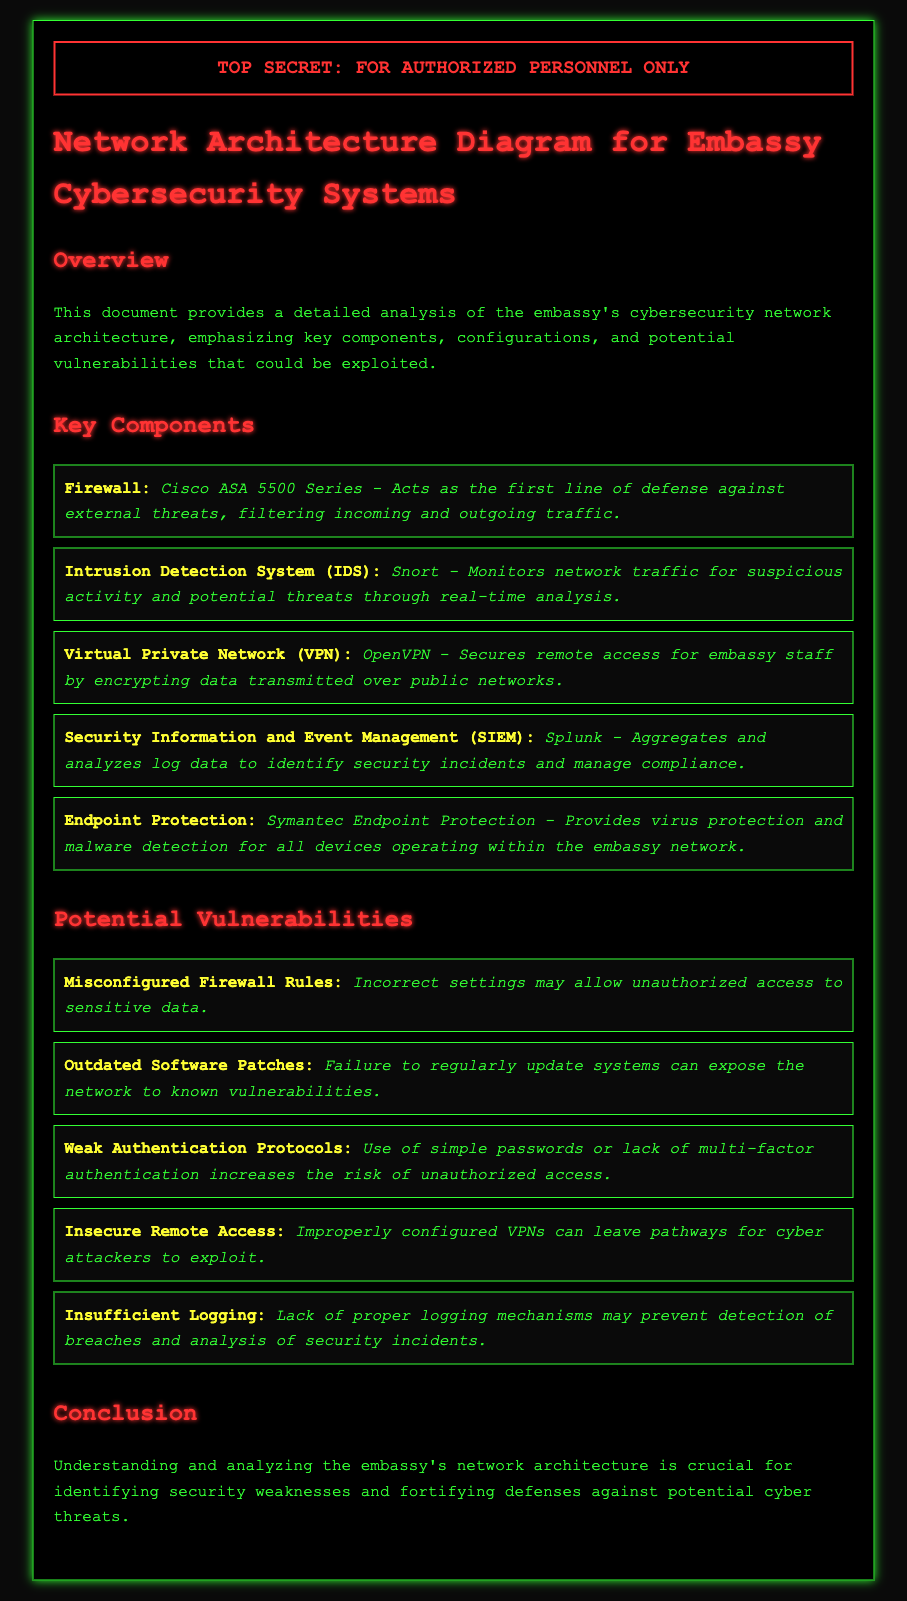what type of firewall is used? The document specifies the use of Cisco ASA 5500 Series as the firewall for the embassy's cybersecurity systems.
Answer: Cisco ASA 5500 Series what system is utilized for intrusion detection? The document mentions Snort as the Intrusion Detection System (IDS) used to monitor network traffic for suspicious activity.
Answer: Snort which VPN is implemented for secure remote access? OpenVPN is identified in the document as the VPN that secures remote access for embassy staff by encrypting data.
Answer: OpenVPN what is a major potential vulnerability related to software? The document highlights "Outdated Software Patches" as a significant potential vulnerability that can expose the network to known threats.
Answer: Outdated Software Patches what can misconfigured firewall rules allow? The document states that misconfigured firewall rules may allow unauthorized access to sensitive data.
Answer: Unauthorized access how does the document classify itself? The document includes a classification header indicating that it is "TOP SECRET: FOR AUTHORIZED PERSONNEL ONLY."
Answer: TOP SECRET what device provides virus protection within the embassy network? The document refers to Symantec Endpoint Protection as the device that provides virus protection and malware detection.
Answer: Symantec Endpoint Protection what is the role of Splunk in the network architecture? According to the document, Splunk aggregates and analyzes log data to identify security incidents and manage compliance.
Answer: Aggregates and analyzes log data which authentication practice increases the risk of unauthorized access? The document specifies "Weak Authentication Protocols" as a practice that increases the risk of unauthorized access.
Answer: Weak Authentication Protocols 